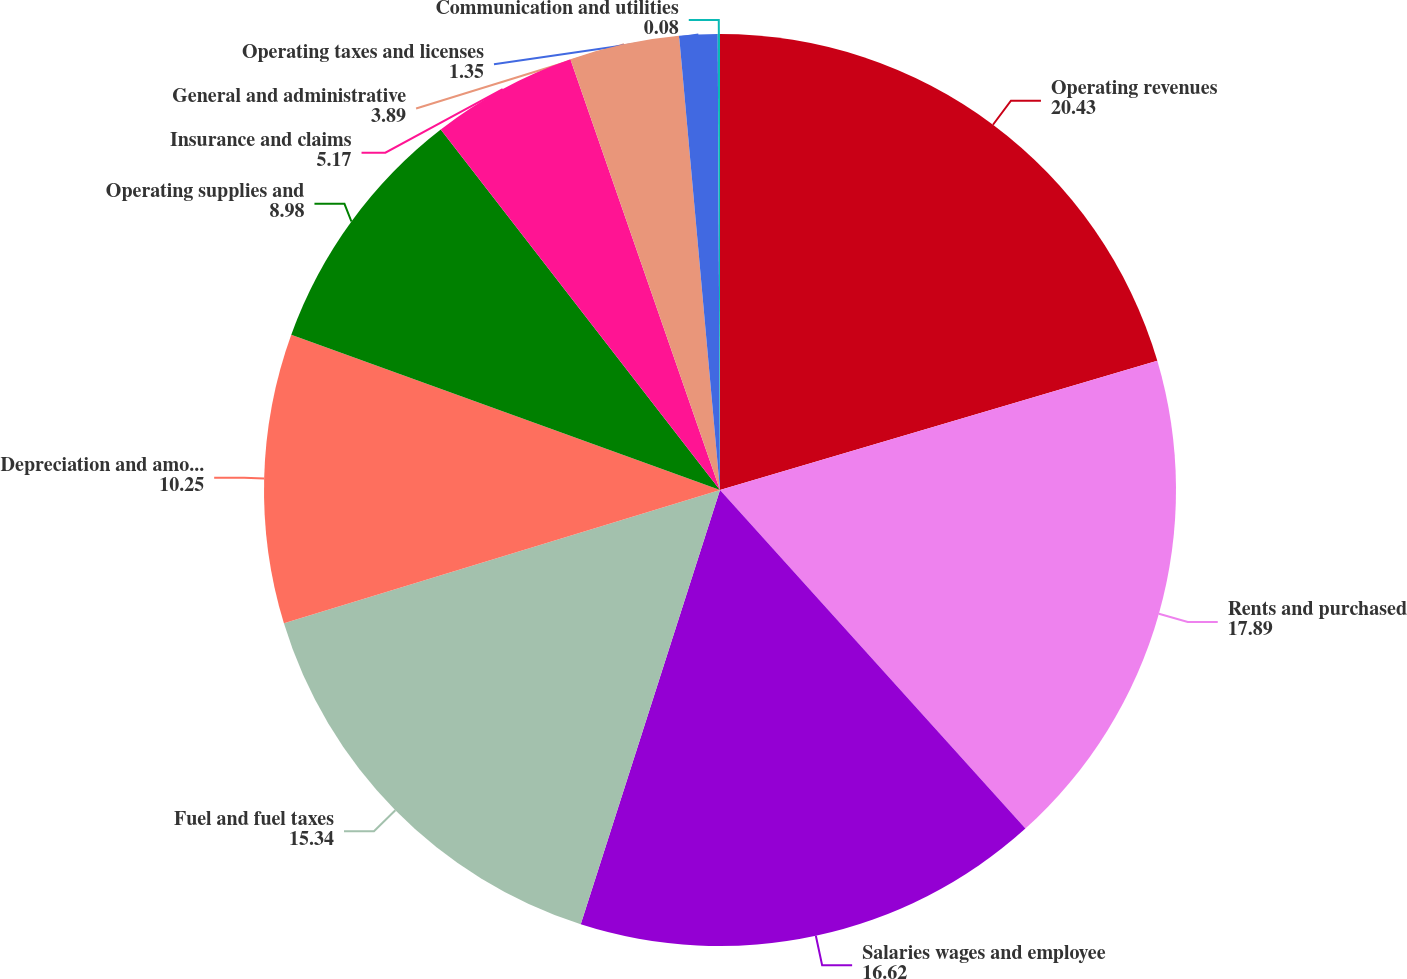Convert chart to OTSL. <chart><loc_0><loc_0><loc_500><loc_500><pie_chart><fcel>Operating revenues<fcel>Rents and purchased<fcel>Salaries wages and employee<fcel>Fuel and fuel taxes<fcel>Depreciation and amortization<fcel>Operating supplies and<fcel>Insurance and claims<fcel>General and administrative<fcel>Operating taxes and licenses<fcel>Communication and utilities<nl><fcel>20.43%<fcel>17.89%<fcel>16.62%<fcel>15.34%<fcel>10.25%<fcel>8.98%<fcel>5.17%<fcel>3.89%<fcel>1.35%<fcel>0.08%<nl></chart> 